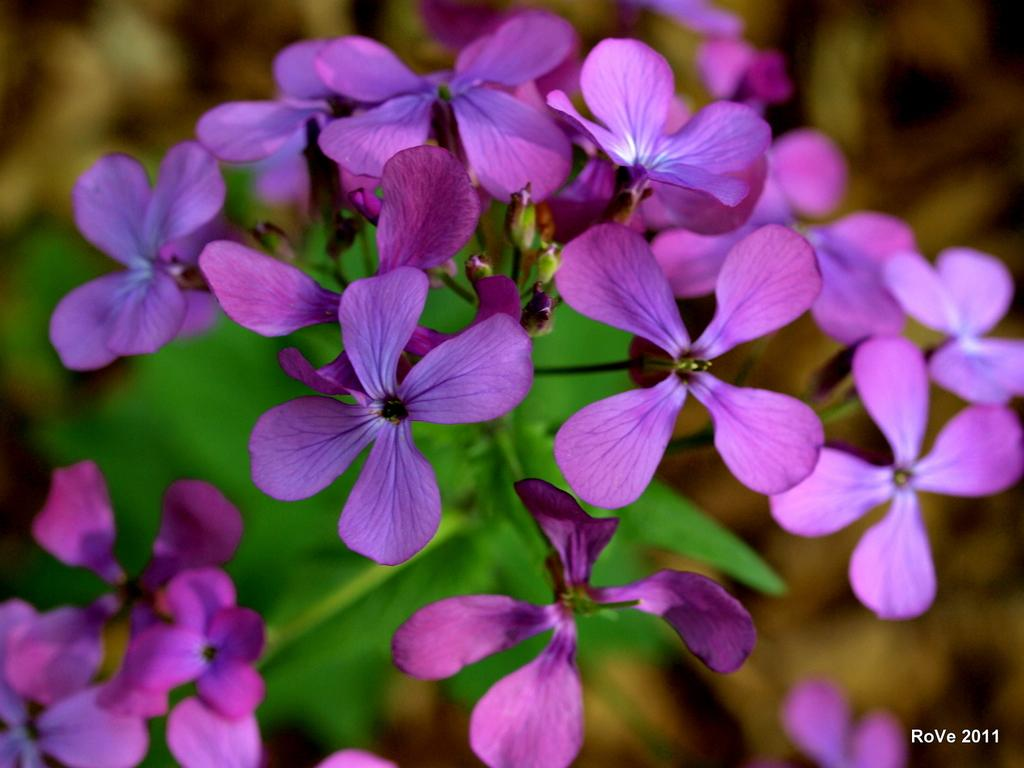What type of flowers can be seen in the image? There are purple color flowers in the image. What stage of growth are the flowers in? There are buds on the plant in the image. Can you describe the clarity of the image? The bottom part of the image is blurry. Is there any text present in the image? Yes, there is text at the bottom right of the image. What type of pancake is being served on the floor in the image? There is no pancake present in the image, and the image does not depict a floor. 